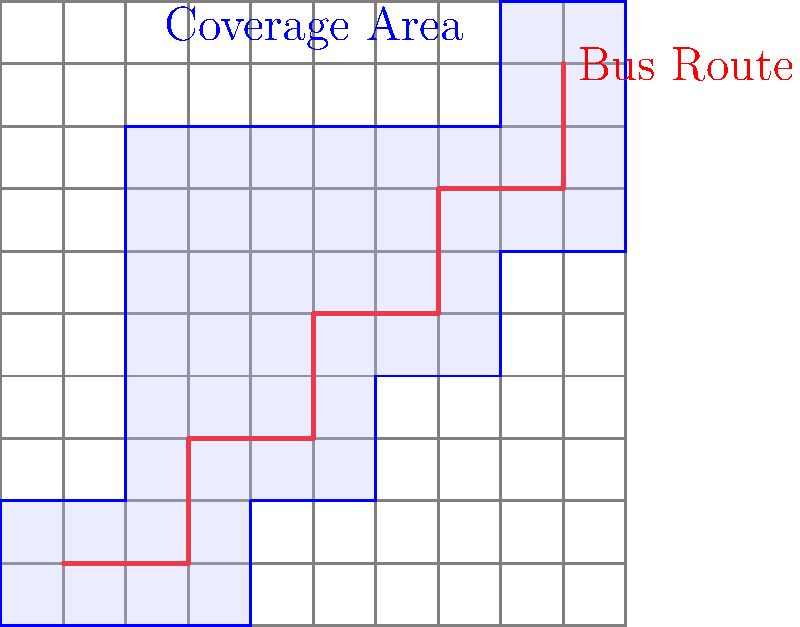The Madera city bus system's route is shown on the grid map above, where each grid square represents 1 square mile. The bus service covers areas within 1 mile of the route. What percentage of the city area is covered by the bus service? To solve this problem, we need to follow these steps:

1. Calculate the total area of the city:
   The grid is 10x10, so the total area is $10 \times 10 = 100$ square miles.

2. Count the number of grid squares covered by the bus service:
   - Full squares: 28
   - Partial squares: 16

3. Calculate the area of partial squares:
   Each partial square is approximately half covered, so we count each as 0.5.
   Area of partial squares: $16 \times 0.5 = 8$ square miles

4. Calculate the total coverage area:
   Total coverage = Full squares + Partial squares
   $28 + 8 = 36$ square miles

5. Calculate the percentage of the city covered:
   Percentage = (Coverage area / Total area) × 100
   $\frac{36}{100} \times 100 = 36\%$

Therefore, the bus service covers 36% of the city area.
Answer: 36% 